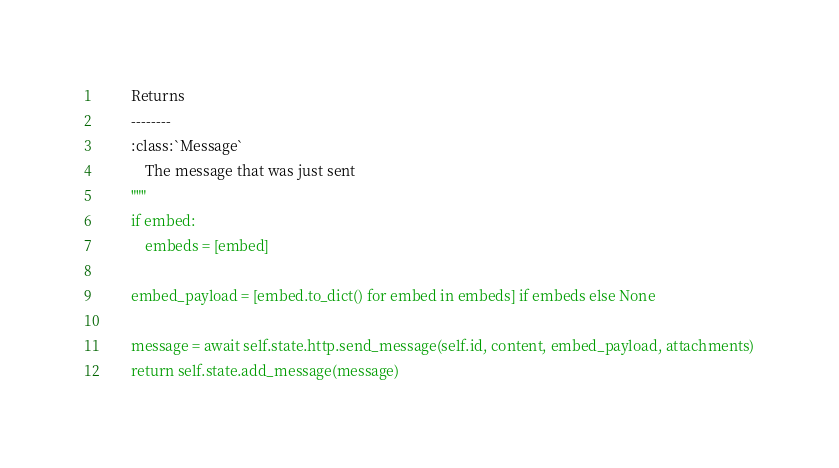<code> <loc_0><loc_0><loc_500><loc_500><_Python_>        Returns
        --------
        :class:`Message`
            The message that was just sent
        """
        if embed:
            embeds = [embed]

        embed_payload = [embed.to_dict() for embed in embeds] if embeds else None

        message = await self.state.http.send_message(self.id, content, embed_payload, attachments)
        return self.state.add_message(message)
</code> 